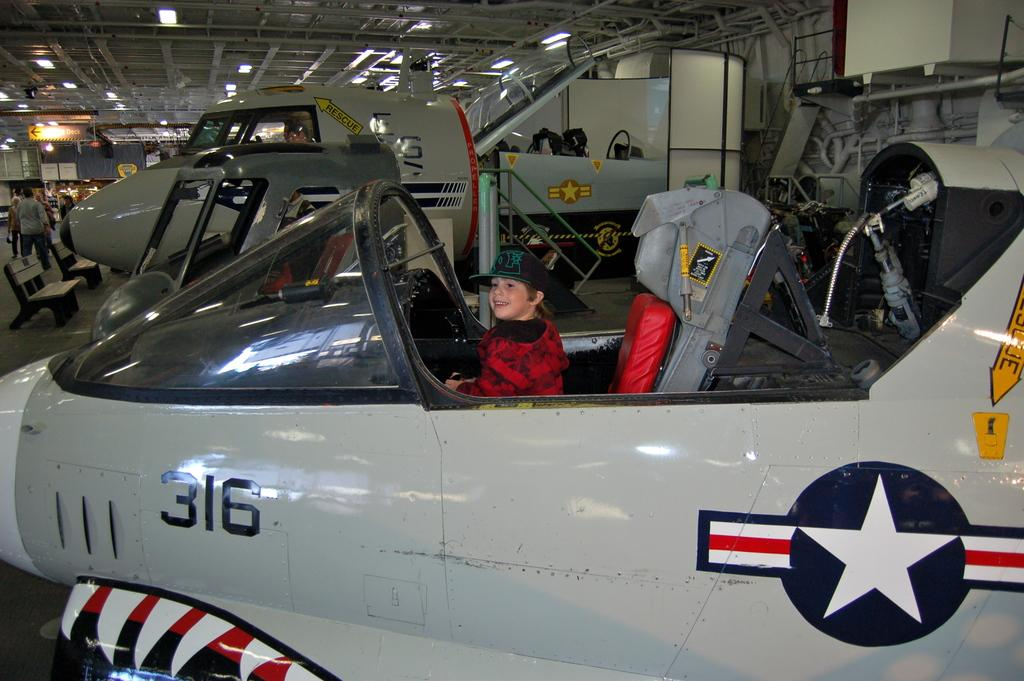Provide a one-sentence caption for the provided image. A kid sits piloting gray painted plane number 316. 